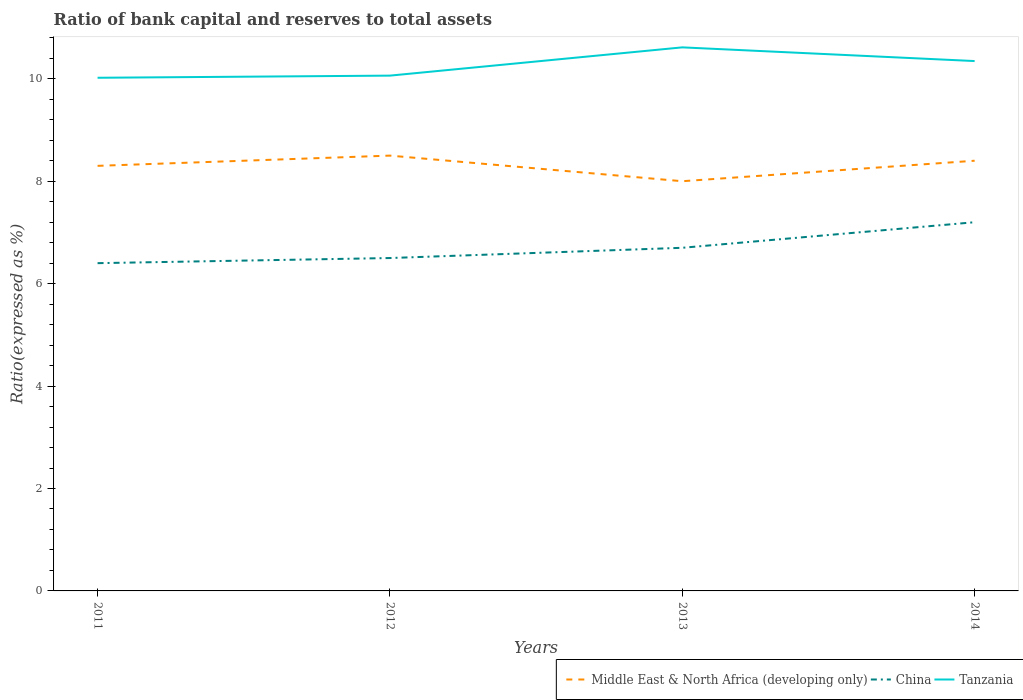How many different coloured lines are there?
Give a very brief answer. 3. Does the line corresponding to Middle East & North Africa (developing only) intersect with the line corresponding to Tanzania?
Keep it short and to the point. No. Across all years, what is the maximum ratio of bank capital and reserves to total assets in Middle East & North Africa (developing only)?
Provide a short and direct response. 8. In which year was the ratio of bank capital and reserves to total assets in Tanzania maximum?
Offer a very short reply. 2011. What is the total ratio of bank capital and reserves to total assets in Tanzania in the graph?
Provide a succinct answer. 0.27. What is the difference between the highest and the second highest ratio of bank capital and reserves to total assets in China?
Your answer should be very brief. 0.8. Is the ratio of bank capital and reserves to total assets in China strictly greater than the ratio of bank capital and reserves to total assets in Middle East & North Africa (developing only) over the years?
Your answer should be very brief. Yes. How many lines are there?
Your response must be concise. 3. What is the difference between two consecutive major ticks on the Y-axis?
Your answer should be very brief. 2. Where does the legend appear in the graph?
Your response must be concise. Bottom right. How many legend labels are there?
Your answer should be compact. 3. How are the legend labels stacked?
Your response must be concise. Horizontal. What is the title of the graph?
Your answer should be compact. Ratio of bank capital and reserves to total assets. Does "Cote d'Ivoire" appear as one of the legend labels in the graph?
Offer a terse response. No. What is the label or title of the X-axis?
Provide a succinct answer. Years. What is the label or title of the Y-axis?
Provide a succinct answer. Ratio(expressed as %). What is the Ratio(expressed as %) of Tanzania in 2011?
Your answer should be very brief. 10.02. What is the Ratio(expressed as %) in Middle East & North Africa (developing only) in 2012?
Provide a short and direct response. 8.5. What is the Ratio(expressed as %) of China in 2012?
Provide a short and direct response. 6.5. What is the Ratio(expressed as %) in Tanzania in 2012?
Give a very brief answer. 10.06. What is the Ratio(expressed as %) of Middle East & North Africa (developing only) in 2013?
Provide a succinct answer. 8. What is the Ratio(expressed as %) of China in 2013?
Give a very brief answer. 6.7. What is the Ratio(expressed as %) in Tanzania in 2013?
Your answer should be very brief. 10.61. What is the Ratio(expressed as %) in Middle East & North Africa (developing only) in 2014?
Your answer should be very brief. 8.4. What is the Ratio(expressed as %) in China in 2014?
Make the answer very short. 7.2. What is the Ratio(expressed as %) of Tanzania in 2014?
Your answer should be very brief. 10.35. Across all years, what is the maximum Ratio(expressed as %) in Middle East & North Africa (developing only)?
Offer a very short reply. 8.5. Across all years, what is the maximum Ratio(expressed as %) of China?
Your answer should be compact. 7.2. Across all years, what is the maximum Ratio(expressed as %) in Tanzania?
Offer a very short reply. 10.61. Across all years, what is the minimum Ratio(expressed as %) in Middle East & North Africa (developing only)?
Keep it short and to the point. 8. Across all years, what is the minimum Ratio(expressed as %) in China?
Your answer should be very brief. 6.4. Across all years, what is the minimum Ratio(expressed as %) in Tanzania?
Keep it short and to the point. 10.02. What is the total Ratio(expressed as %) of Middle East & North Africa (developing only) in the graph?
Keep it short and to the point. 33.2. What is the total Ratio(expressed as %) in China in the graph?
Ensure brevity in your answer.  26.8. What is the total Ratio(expressed as %) in Tanzania in the graph?
Give a very brief answer. 41.04. What is the difference between the Ratio(expressed as %) of Middle East & North Africa (developing only) in 2011 and that in 2012?
Provide a short and direct response. -0.2. What is the difference between the Ratio(expressed as %) of China in 2011 and that in 2012?
Your answer should be compact. -0.1. What is the difference between the Ratio(expressed as %) of Tanzania in 2011 and that in 2012?
Ensure brevity in your answer.  -0.04. What is the difference between the Ratio(expressed as %) in Middle East & North Africa (developing only) in 2011 and that in 2013?
Keep it short and to the point. 0.3. What is the difference between the Ratio(expressed as %) of Tanzania in 2011 and that in 2013?
Offer a very short reply. -0.59. What is the difference between the Ratio(expressed as %) of China in 2011 and that in 2014?
Your answer should be very brief. -0.8. What is the difference between the Ratio(expressed as %) of Tanzania in 2011 and that in 2014?
Ensure brevity in your answer.  -0.33. What is the difference between the Ratio(expressed as %) of Tanzania in 2012 and that in 2013?
Offer a terse response. -0.55. What is the difference between the Ratio(expressed as %) in Middle East & North Africa (developing only) in 2012 and that in 2014?
Provide a succinct answer. 0.1. What is the difference between the Ratio(expressed as %) of China in 2012 and that in 2014?
Your response must be concise. -0.7. What is the difference between the Ratio(expressed as %) in Tanzania in 2012 and that in 2014?
Offer a very short reply. -0.28. What is the difference between the Ratio(expressed as %) in Middle East & North Africa (developing only) in 2013 and that in 2014?
Ensure brevity in your answer.  -0.4. What is the difference between the Ratio(expressed as %) in China in 2013 and that in 2014?
Provide a succinct answer. -0.5. What is the difference between the Ratio(expressed as %) of Tanzania in 2013 and that in 2014?
Offer a very short reply. 0.27. What is the difference between the Ratio(expressed as %) in Middle East & North Africa (developing only) in 2011 and the Ratio(expressed as %) in Tanzania in 2012?
Your answer should be compact. -1.76. What is the difference between the Ratio(expressed as %) in China in 2011 and the Ratio(expressed as %) in Tanzania in 2012?
Provide a short and direct response. -3.66. What is the difference between the Ratio(expressed as %) in Middle East & North Africa (developing only) in 2011 and the Ratio(expressed as %) in China in 2013?
Give a very brief answer. 1.6. What is the difference between the Ratio(expressed as %) in Middle East & North Africa (developing only) in 2011 and the Ratio(expressed as %) in Tanzania in 2013?
Ensure brevity in your answer.  -2.31. What is the difference between the Ratio(expressed as %) of China in 2011 and the Ratio(expressed as %) of Tanzania in 2013?
Your answer should be compact. -4.21. What is the difference between the Ratio(expressed as %) in Middle East & North Africa (developing only) in 2011 and the Ratio(expressed as %) in China in 2014?
Ensure brevity in your answer.  1.1. What is the difference between the Ratio(expressed as %) in Middle East & North Africa (developing only) in 2011 and the Ratio(expressed as %) in Tanzania in 2014?
Offer a very short reply. -2.05. What is the difference between the Ratio(expressed as %) of China in 2011 and the Ratio(expressed as %) of Tanzania in 2014?
Provide a short and direct response. -3.95. What is the difference between the Ratio(expressed as %) of Middle East & North Africa (developing only) in 2012 and the Ratio(expressed as %) of China in 2013?
Provide a succinct answer. 1.8. What is the difference between the Ratio(expressed as %) of Middle East & North Africa (developing only) in 2012 and the Ratio(expressed as %) of Tanzania in 2013?
Give a very brief answer. -2.11. What is the difference between the Ratio(expressed as %) of China in 2012 and the Ratio(expressed as %) of Tanzania in 2013?
Provide a succinct answer. -4.11. What is the difference between the Ratio(expressed as %) of Middle East & North Africa (developing only) in 2012 and the Ratio(expressed as %) of China in 2014?
Your answer should be compact. 1.3. What is the difference between the Ratio(expressed as %) in Middle East & North Africa (developing only) in 2012 and the Ratio(expressed as %) in Tanzania in 2014?
Your answer should be compact. -1.85. What is the difference between the Ratio(expressed as %) in China in 2012 and the Ratio(expressed as %) in Tanzania in 2014?
Offer a very short reply. -3.85. What is the difference between the Ratio(expressed as %) in Middle East & North Africa (developing only) in 2013 and the Ratio(expressed as %) in China in 2014?
Offer a terse response. 0.8. What is the difference between the Ratio(expressed as %) of Middle East & North Africa (developing only) in 2013 and the Ratio(expressed as %) of Tanzania in 2014?
Offer a very short reply. -2.35. What is the difference between the Ratio(expressed as %) in China in 2013 and the Ratio(expressed as %) in Tanzania in 2014?
Provide a short and direct response. -3.65. What is the average Ratio(expressed as %) in Middle East & North Africa (developing only) per year?
Give a very brief answer. 8.3. What is the average Ratio(expressed as %) in China per year?
Offer a terse response. 6.7. What is the average Ratio(expressed as %) of Tanzania per year?
Offer a very short reply. 10.26. In the year 2011, what is the difference between the Ratio(expressed as %) of Middle East & North Africa (developing only) and Ratio(expressed as %) of Tanzania?
Your answer should be very brief. -1.72. In the year 2011, what is the difference between the Ratio(expressed as %) of China and Ratio(expressed as %) of Tanzania?
Give a very brief answer. -3.62. In the year 2012, what is the difference between the Ratio(expressed as %) of Middle East & North Africa (developing only) and Ratio(expressed as %) of China?
Offer a terse response. 2. In the year 2012, what is the difference between the Ratio(expressed as %) in Middle East & North Africa (developing only) and Ratio(expressed as %) in Tanzania?
Your response must be concise. -1.56. In the year 2012, what is the difference between the Ratio(expressed as %) in China and Ratio(expressed as %) in Tanzania?
Offer a terse response. -3.56. In the year 2013, what is the difference between the Ratio(expressed as %) in Middle East & North Africa (developing only) and Ratio(expressed as %) in China?
Provide a succinct answer. 1.3. In the year 2013, what is the difference between the Ratio(expressed as %) in Middle East & North Africa (developing only) and Ratio(expressed as %) in Tanzania?
Ensure brevity in your answer.  -2.61. In the year 2013, what is the difference between the Ratio(expressed as %) of China and Ratio(expressed as %) of Tanzania?
Keep it short and to the point. -3.91. In the year 2014, what is the difference between the Ratio(expressed as %) of Middle East & North Africa (developing only) and Ratio(expressed as %) of China?
Provide a succinct answer. 1.2. In the year 2014, what is the difference between the Ratio(expressed as %) of Middle East & North Africa (developing only) and Ratio(expressed as %) of Tanzania?
Keep it short and to the point. -1.95. In the year 2014, what is the difference between the Ratio(expressed as %) in China and Ratio(expressed as %) in Tanzania?
Make the answer very short. -3.15. What is the ratio of the Ratio(expressed as %) in Middle East & North Africa (developing only) in 2011 to that in 2012?
Provide a short and direct response. 0.98. What is the ratio of the Ratio(expressed as %) of China in 2011 to that in 2012?
Your answer should be very brief. 0.98. What is the ratio of the Ratio(expressed as %) in Middle East & North Africa (developing only) in 2011 to that in 2013?
Ensure brevity in your answer.  1.04. What is the ratio of the Ratio(expressed as %) of China in 2011 to that in 2013?
Keep it short and to the point. 0.96. What is the ratio of the Ratio(expressed as %) in Tanzania in 2011 to that in 2013?
Give a very brief answer. 0.94. What is the ratio of the Ratio(expressed as %) in China in 2011 to that in 2014?
Ensure brevity in your answer.  0.89. What is the ratio of the Ratio(expressed as %) in Tanzania in 2011 to that in 2014?
Your answer should be very brief. 0.97. What is the ratio of the Ratio(expressed as %) of China in 2012 to that in 2013?
Your answer should be compact. 0.97. What is the ratio of the Ratio(expressed as %) of Tanzania in 2012 to that in 2013?
Your answer should be compact. 0.95. What is the ratio of the Ratio(expressed as %) in Middle East & North Africa (developing only) in 2012 to that in 2014?
Provide a succinct answer. 1.01. What is the ratio of the Ratio(expressed as %) in China in 2012 to that in 2014?
Offer a terse response. 0.9. What is the ratio of the Ratio(expressed as %) of Tanzania in 2012 to that in 2014?
Your answer should be very brief. 0.97. What is the ratio of the Ratio(expressed as %) of Middle East & North Africa (developing only) in 2013 to that in 2014?
Provide a succinct answer. 0.95. What is the ratio of the Ratio(expressed as %) of China in 2013 to that in 2014?
Make the answer very short. 0.93. What is the ratio of the Ratio(expressed as %) of Tanzania in 2013 to that in 2014?
Make the answer very short. 1.03. What is the difference between the highest and the second highest Ratio(expressed as %) in Middle East & North Africa (developing only)?
Offer a terse response. 0.1. What is the difference between the highest and the second highest Ratio(expressed as %) of China?
Give a very brief answer. 0.5. What is the difference between the highest and the second highest Ratio(expressed as %) in Tanzania?
Provide a succinct answer. 0.27. What is the difference between the highest and the lowest Ratio(expressed as %) of China?
Your answer should be very brief. 0.8. What is the difference between the highest and the lowest Ratio(expressed as %) in Tanzania?
Offer a terse response. 0.59. 